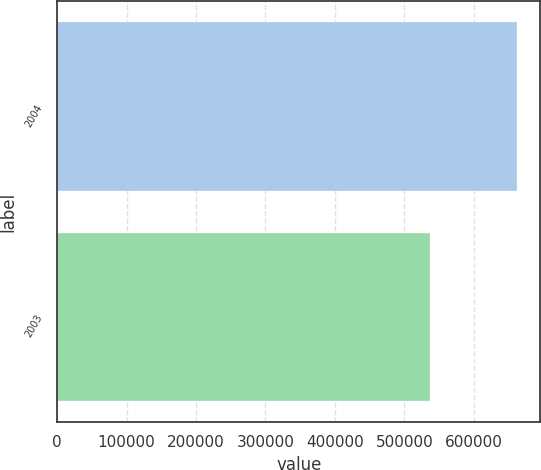Convert chart to OTSL. <chart><loc_0><loc_0><loc_500><loc_500><bar_chart><fcel>2004<fcel>2003<nl><fcel>663054<fcel>536397<nl></chart> 